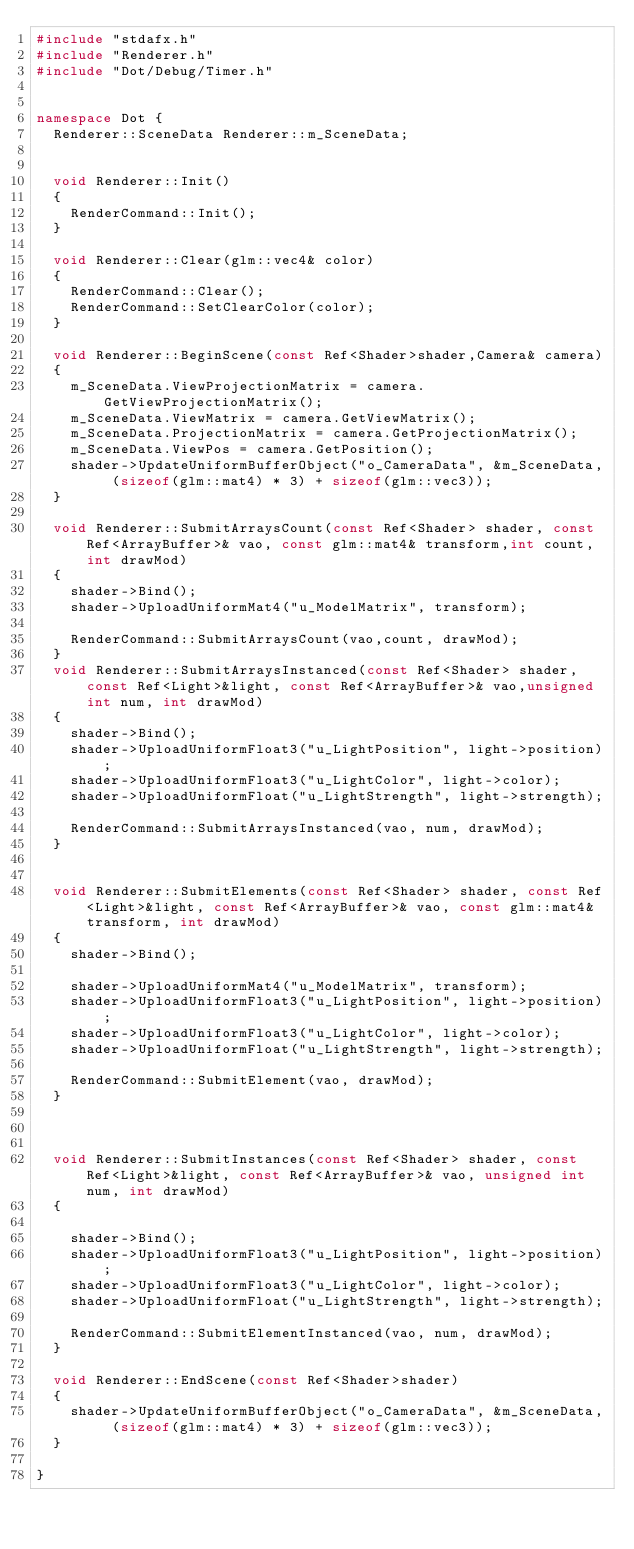<code> <loc_0><loc_0><loc_500><loc_500><_C++_>#include "stdafx.h"
#include "Renderer.h"
#include "Dot/Debug/Timer.h"


namespace Dot {
	Renderer::SceneData Renderer::m_SceneData;


	void Renderer::Init()
	{
		RenderCommand::Init();
	}

	void Renderer::Clear(glm::vec4& color)
	{
		RenderCommand::Clear();
		RenderCommand::SetClearColor(color);
	}

	void Renderer::BeginScene(const Ref<Shader>shader,Camera& camera)
	{
		m_SceneData.ViewProjectionMatrix = camera.GetViewProjectionMatrix();
		m_SceneData.ViewMatrix = camera.GetViewMatrix();
		m_SceneData.ProjectionMatrix = camera.GetProjectionMatrix();
		m_SceneData.ViewPos = camera.GetPosition();
		shader->UpdateUniformBufferObject("o_CameraData", &m_SceneData, (sizeof(glm::mat4) * 3) + sizeof(glm::vec3));
	}

	void Renderer::SubmitArraysCount(const Ref<Shader> shader, const Ref<ArrayBuffer>& vao, const glm::mat4& transform,int count, int drawMod)
	{
		shader->Bind();
		shader->UploadUniformMat4("u_ModelMatrix", transform);

		RenderCommand::SubmitArraysCount(vao,count, drawMod);
	}
	void Renderer::SubmitArraysInstanced(const Ref<Shader> shader, const Ref<Light>&light, const Ref<ArrayBuffer>& vao,unsigned int num, int drawMod)
	{
		shader->Bind();
		shader->UploadUniformFloat3("u_LightPosition", light->position);
		shader->UploadUniformFloat3("u_LightColor", light->color);
		shader->UploadUniformFloat("u_LightStrength", light->strength);

		RenderCommand::SubmitArraysInstanced(vao, num, drawMod);
	}


	void Renderer::SubmitElements(const Ref<Shader> shader, const Ref<Light>&light, const Ref<ArrayBuffer>& vao, const glm::mat4& transform, int drawMod)
	{
		shader->Bind();

		shader->UploadUniformMat4("u_ModelMatrix", transform);
		shader->UploadUniformFloat3("u_LightPosition", light->position);
		shader->UploadUniformFloat3("u_LightColor", light->color);
		shader->UploadUniformFloat("u_LightStrength", light->strength);

		RenderCommand::SubmitElement(vao, drawMod);
	}



	void Renderer::SubmitInstances(const Ref<Shader> shader, const Ref<Light>&light, const Ref<ArrayBuffer>& vao, unsigned int num, int drawMod)
	{

		shader->Bind();
		shader->UploadUniformFloat3("u_LightPosition", light->position);
		shader->UploadUniformFloat3("u_LightColor", light->color);
		shader->UploadUniformFloat("u_LightStrength", light->strength);
		
		RenderCommand::SubmitElementInstanced(vao, num, drawMod);
	}

	void Renderer::EndScene(const Ref<Shader>shader)
	{
		shader->UpdateUniformBufferObject("o_CameraData", &m_SceneData, (sizeof(glm::mat4) * 3) + sizeof(glm::vec3));
	}

}</code> 